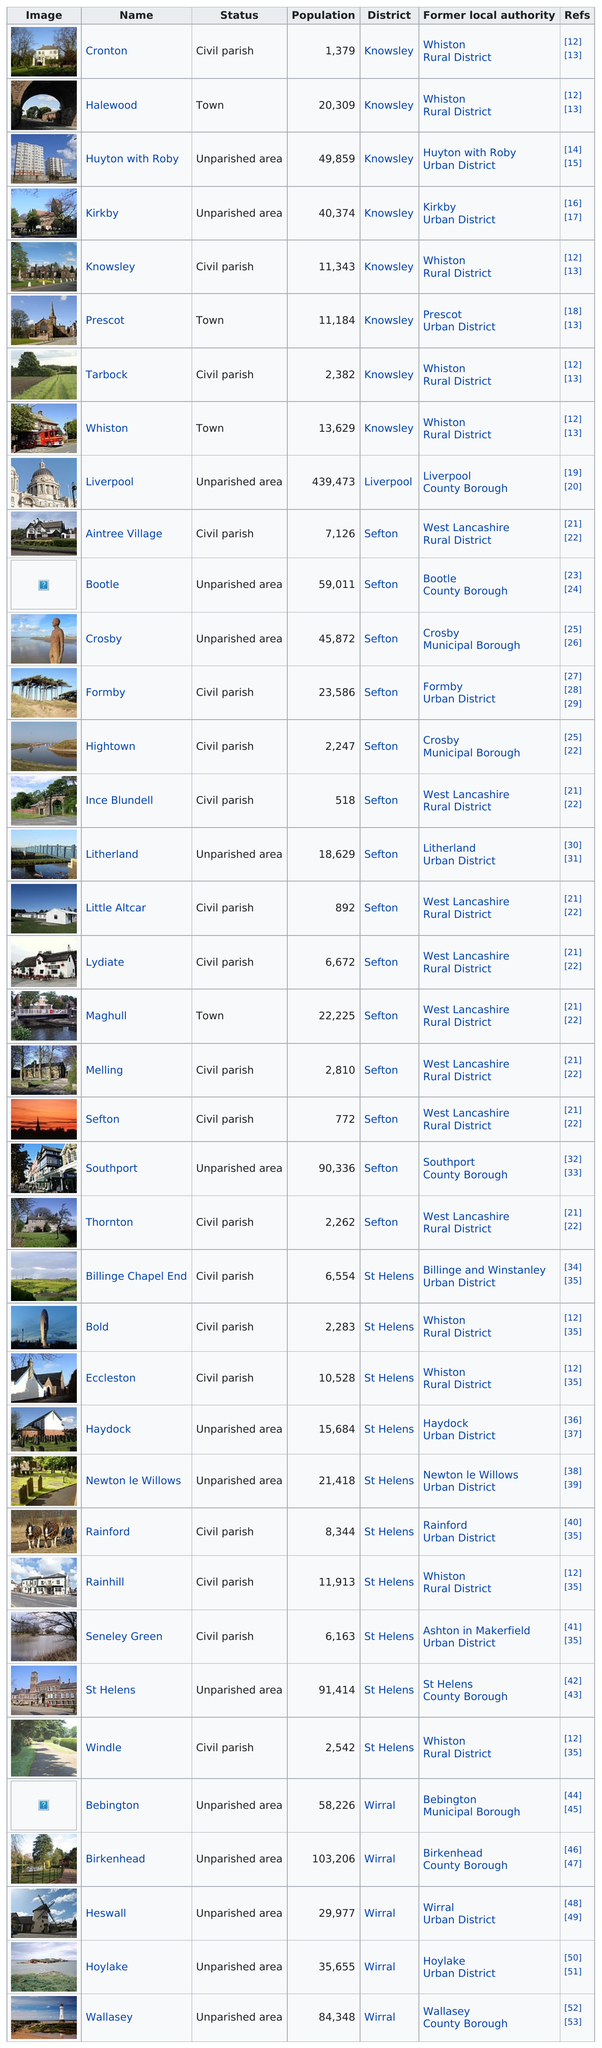Identify some key points in this picture. There are approximately 2,283 people living in the bold civil parish. Four civil parishes have a population count of at least 10,000. There are 15 unparished areas. Haydock, a previously unparished area, is located in the Birkenhead region with the lowest population of residents. The largest area in terms of population is Liverpool. 